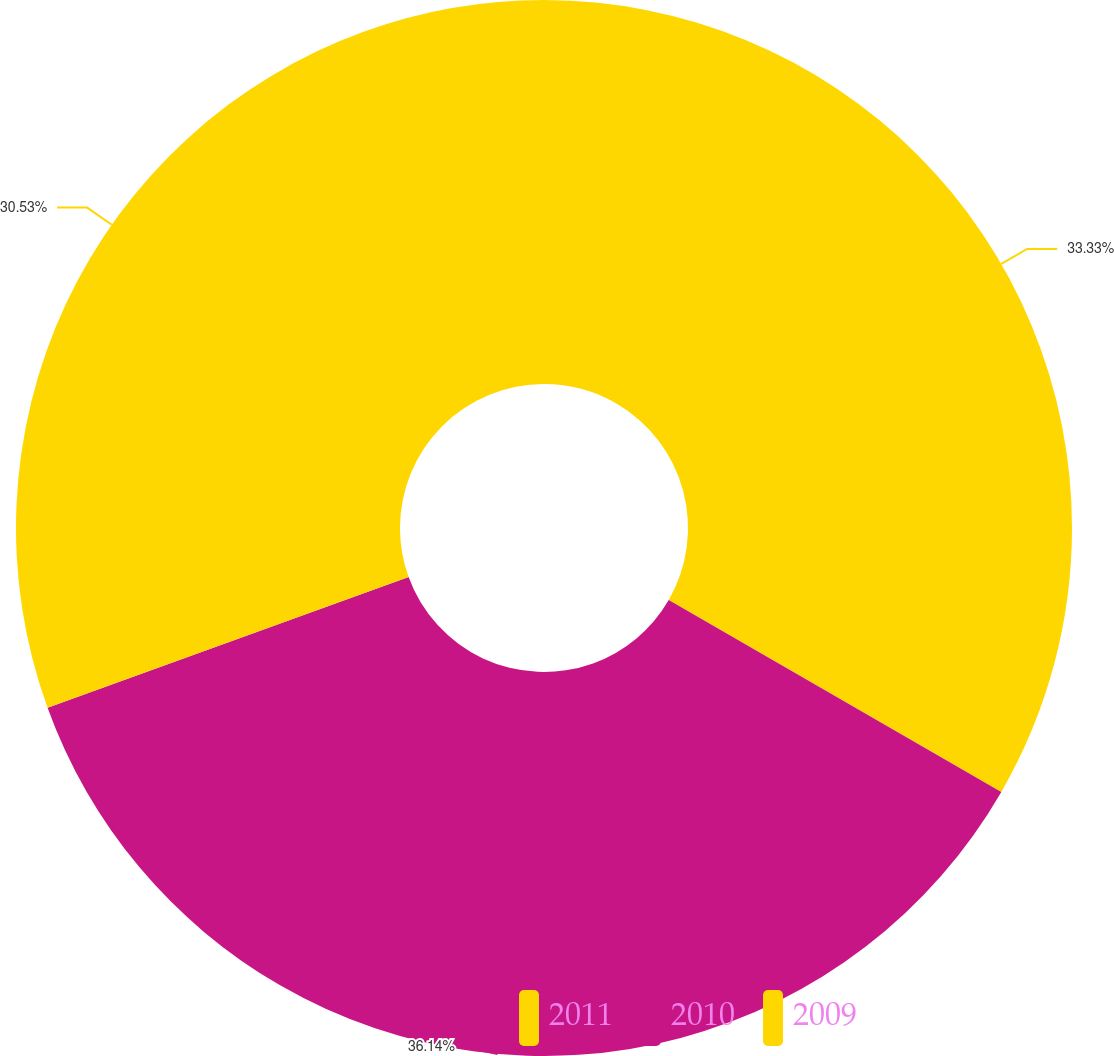Convert chart. <chart><loc_0><loc_0><loc_500><loc_500><pie_chart><fcel>2011<fcel>2010<fcel>2009<nl><fcel>33.33%<fcel>36.14%<fcel>30.53%<nl></chart> 